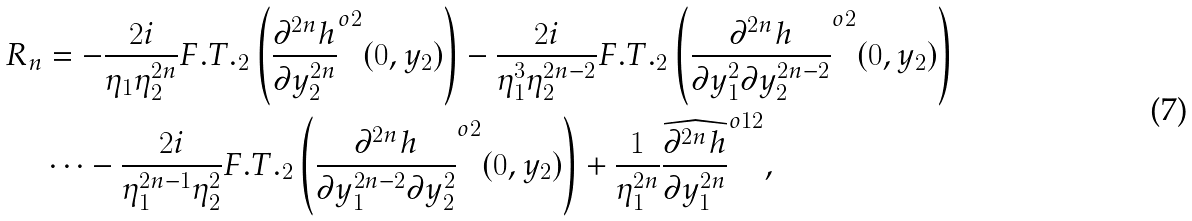<formula> <loc_0><loc_0><loc_500><loc_500>R _ { n } & = - \frac { 2 i } { \eta _ { 1 } \eta _ { 2 } ^ { 2 n } } F . T . _ { 2 } \left ( \frac { \partial ^ { 2 n } h } { \partial y _ { 2 } ^ { 2 n } } ^ { o 2 } ( 0 , y _ { 2 } ) \right ) - \frac { 2 i } { \eta _ { 1 } ^ { 3 } \eta _ { 2 } ^ { 2 n - 2 } } F . T . _ { 2 } \left ( \frac { \partial ^ { 2 n } h } { \partial y _ { 1 } ^ { 2 } \partial y _ { 2 } ^ { 2 n - 2 } } ^ { o 2 } ( 0 , y _ { 2 } ) \right ) \\ & \cdots - \frac { 2 i } { \eta _ { 1 } ^ { 2 n - 1 } \eta _ { 2 } ^ { 2 } } F . T . _ { 2 } \left ( \frac { \partial ^ { 2 n } h } { \partial y _ { 1 } ^ { 2 n - 2 } \partial y _ { 2 } ^ { 2 } } ^ { o 2 } ( 0 , y _ { 2 } ) \right ) + \frac { 1 } { \eta _ { 1 } ^ { 2 n } } \frac { \widehat { \partial ^ { 2 n } h } } { \partial y _ { 1 } ^ { 2 n } } ^ { o 1 2 } ,</formula> 